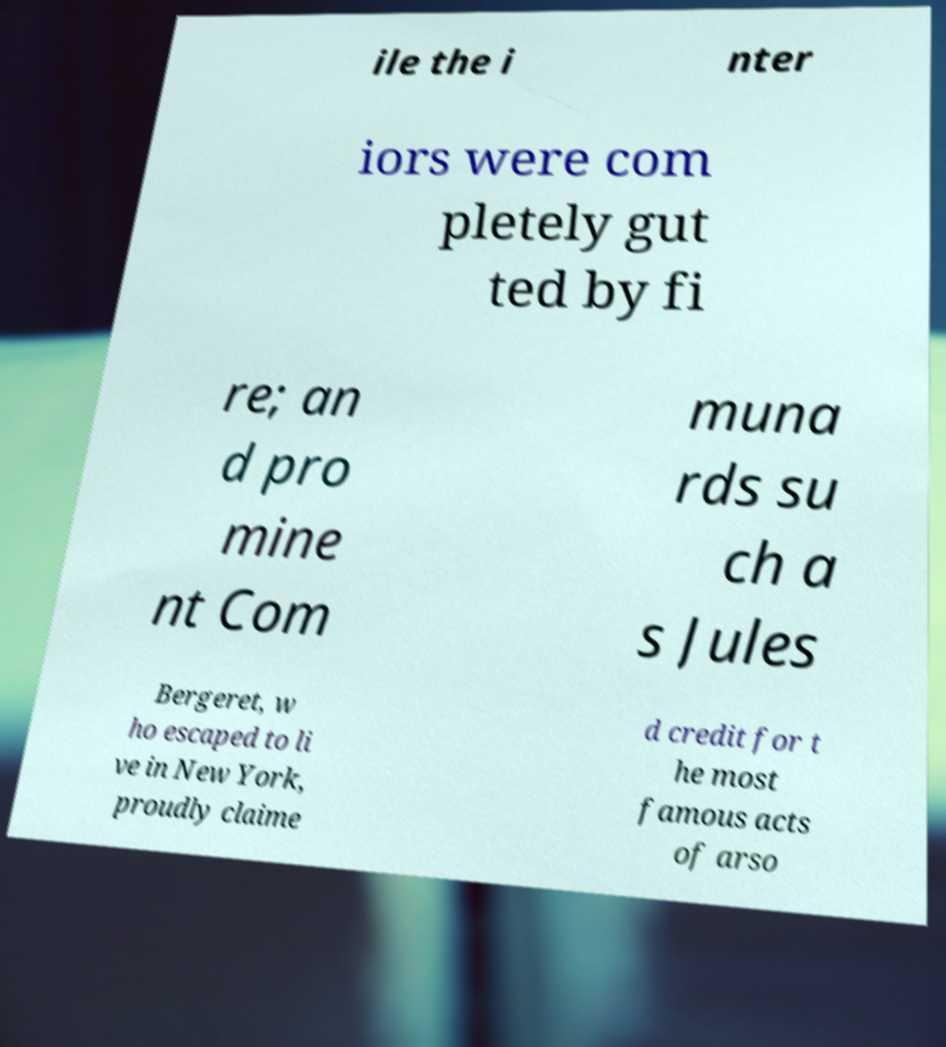Could you extract and type out the text from this image? ile the i nter iors were com pletely gut ted by fi re; an d pro mine nt Com muna rds su ch a s Jules Bergeret, w ho escaped to li ve in New York, proudly claime d credit for t he most famous acts of arso 